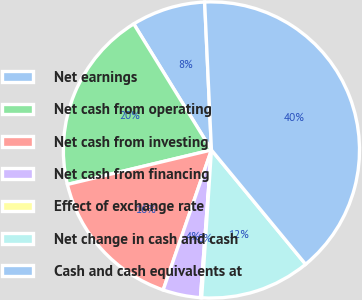Convert chart to OTSL. <chart><loc_0><loc_0><loc_500><loc_500><pie_chart><fcel>Net earnings<fcel>Net cash from operating<fcel>Net cash from investing<fcel>Net cash from financing<fcel>Effect of exchange rate<fcel>Net change in cash and cash<fcel>Cash and cash equivalents at<nl><fcel>8.06%<fcel>19.95%<fcel>15.98%<fcel>4.1%<fcel>0.13%<fcel>12.02%<fcel>39.76%<nl></chart> 